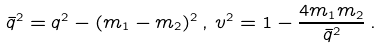<formula> <loc_0><loc_0><loc_500><loc_500>\bar { q } ^ { 2 } = q ^ { 2 } - ( m _ { 1 } - m _ { 2 } ) ^ { 2 } \, , \, v ^ { 2 } = 1 - \frac { 4 m _ { 1 } m _ { 2 } } { \bar { q } ^ { 2 } } \, .</formula> 